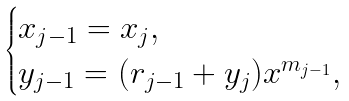Convert formula to latex. <formula><loc_0><loc_0><loc_500><loc_500>\begin{cases} x _ { j - 1 } = x _ { j } , \\ y _ { j - 1 } = ( r _ { j - 1 } + y _ { j } ) x ^ { m _ { j - 1 } } , \end{cases}</formula> 